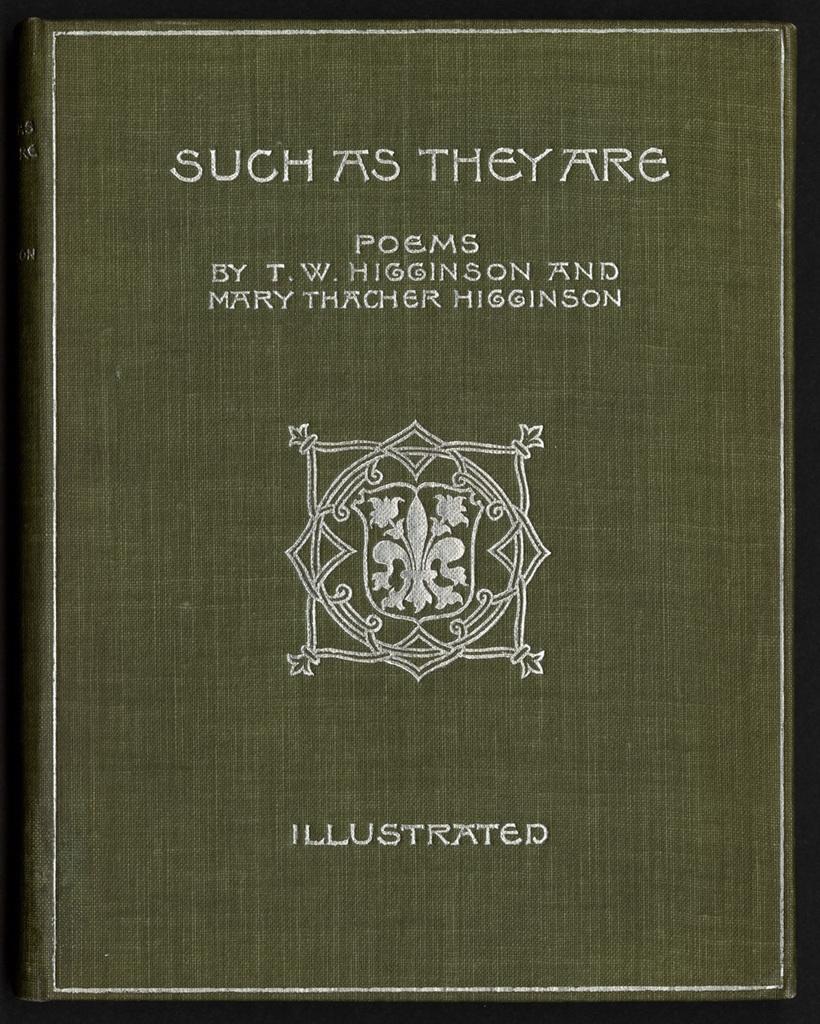What is this book?
Your answer should be very brief. Such as they are. 